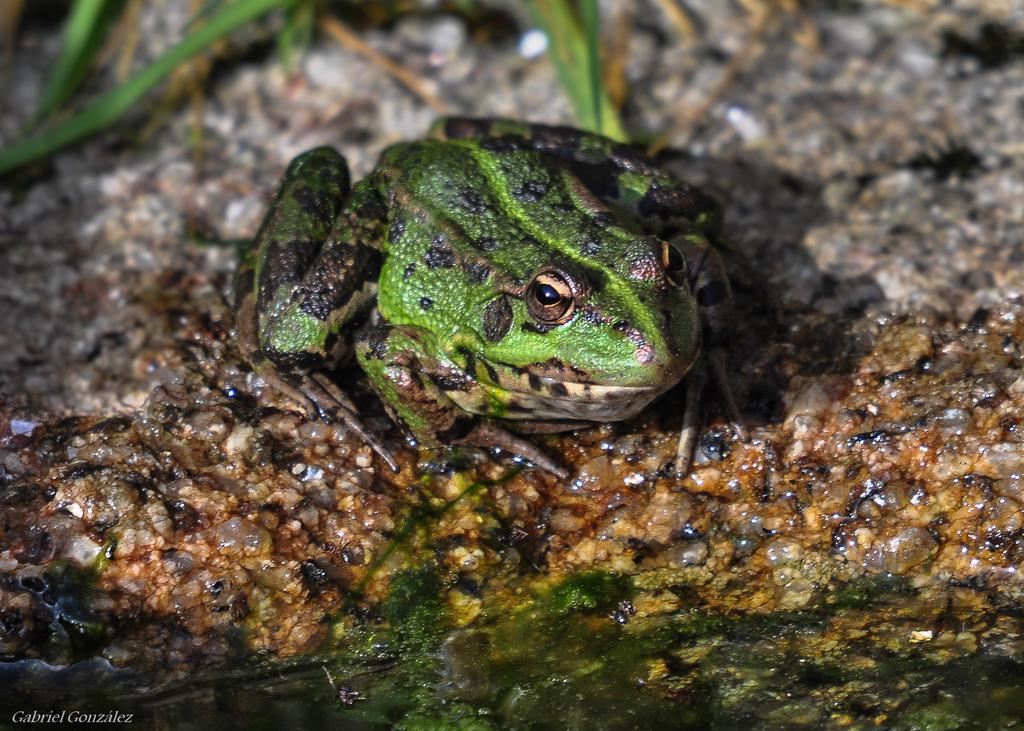What type of animal is in the image? There is a green frog in the image. Where is the frog located? The frog is on a stone. What can be seen in the foreground of the image? There is water in the foreground of the image. What is visible in the background of the image? There are leaves in the background of the image. How many sisters does the secretary have in the image? There is no secretary or sisters present in the image; it features a green frog on a stone with water and leaves in the background. 